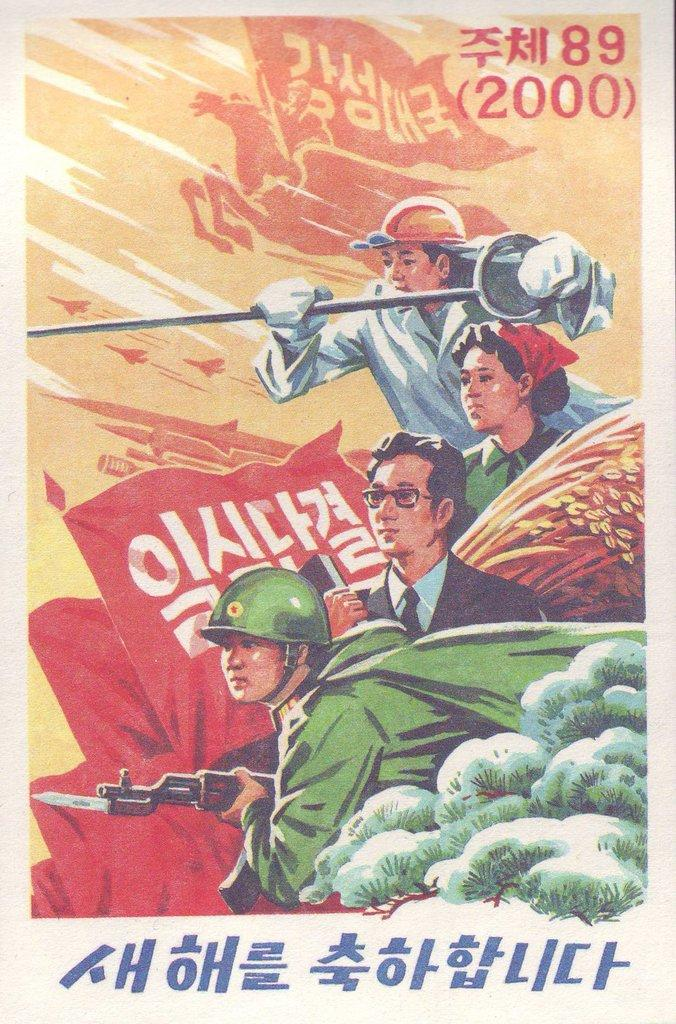<image>
Summarize the visual content of the image. Poster showing people in a war and the year 2000. 